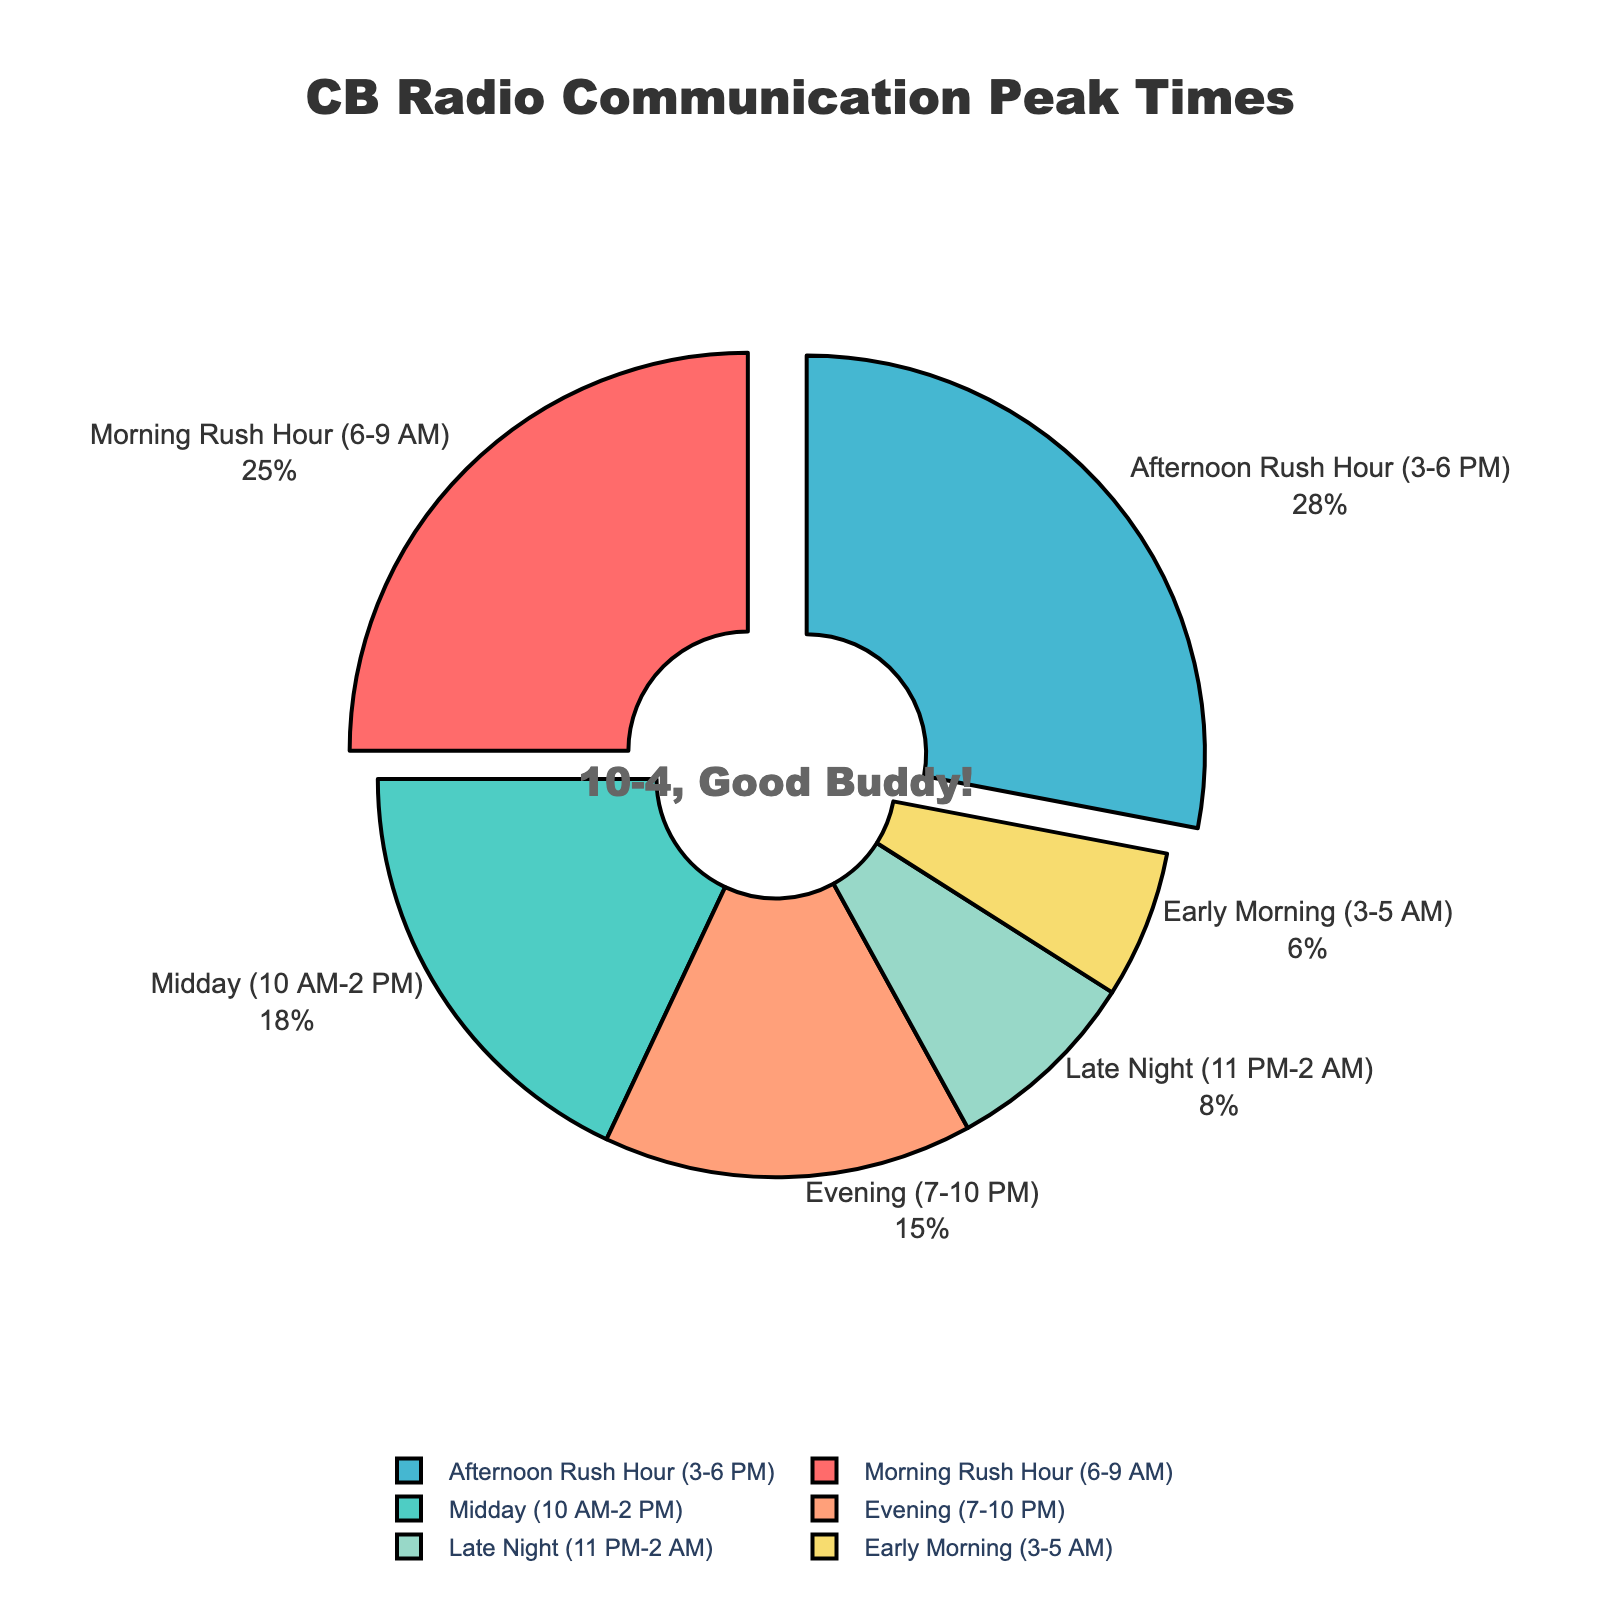Which time of day has the highest percentage of CB radio communication? By looking at the pie chart, the largest segment indicates the highest percentage. The "Afternoon Rush Hour (3-6 PM)" section is the largest, representing 28% of CB radio communication.
Answer: Afternoon Rush Hour (3-6 PM) Which time intervals together account for more than half of the total CB radio communications? To find the total percentage exceeding 50%, summing the largest sections first gives an efficient result. Combining "Afternoon Rush Hour (3-6 PM)" at 28% and "Morning Rush Hour (6-9 AM)" at 25% yields 53%, which surpasses half of the total.
Answer: Morning Rush Hour and Afternoon Rush Hour Which time of day has the least CB radio usage, and what is its percentage? By identifying the smallest segment in the pie chart, the "Early Morning (3-5 AM)" section is the smallest, representing 6%.
Answer: Early Morning (3-5 AM), 6% How much greater is the percentage of CB radio communication during the Morning Rush Hour compared to the Late Night? Subtracting the percentage of "Late Night (11 PM-2 AM)" at 8% from "Morning Rush Hour (6-9 AM)" at 25% gives the difference. 25 - 8 = 17%.
Answer: 17% What is the combined percentage for Midday and Evening CB radio communications? Summing up the individual percentages for "Midday (10 AM-2 PM)" at 18% and "Evening (7-10 PM)" at 15% gives 18 + 15 = 33%.
Answer: 33% Which time intervals have a pull effect in the pie chart, and what might be the reason for this? Observing the visual presentation, "Morning Rush Hour (6-9 AM)" and "Afternoon Rush Hour (3-6 PM)" are slightly pulled out. This pull effect typically emphasizes the critical intervals with higher user engagement.
Answer: Morning Rush Hour and Afternoon Rush Hour What is the percentage difference between the Late Night and Early Morning periods? Calculating the difference by subtracting "Early Morning (3-5 AM)" at 6% from "Late Night (11 PM-2 AM)" at 8% yields 8 - 6 = 2%.
Answer: 2% How does the percentage of CB radio usage in the Evening compare to the Midday? Comparing the two percentages, "Evening (7-10 PM)" at 15% is slightly less than "Midday (10 AM-2 PM)" at 18%. Subtracting gives 18 - 15 = 3%.
Answer: Midday is 3% higher than Evening What proportion of the pie chart does the Morning Rush Hour occupy visually? The pie chart shows percentages with labeled sections. "Morning Rush Hour (6-9 AM)" occupies 25% of the pie chart.
Answer: 25% What percentage of CB radio communications occur outside rush hours? Adding the percentages for non-rush hour intervals: "Midday (10 AM-2 PM)" at 18%, "Evening (7-10 PM)" at 15%, "Late Night (11 PM-2 AM)" at 8%, and "Early Morning (3-5 AM)" at 6%, results in a total of 18 + 15 + 8 + 6 = 47%.
Answer: 47% 